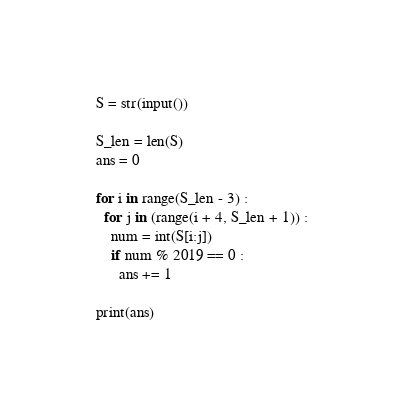<code> <loc_0><loc_0><loc_500><loc_500><_Python_>S = str(input())

S_len = len(S)
ans = 0

for i in range(S_len - 3) :
  for j in (range(i + 4, S_len + 1)) :
    num = int(S[i:j])
    if num % 2019 == 0 :
      ans += 1
      
print(ans)</code> 